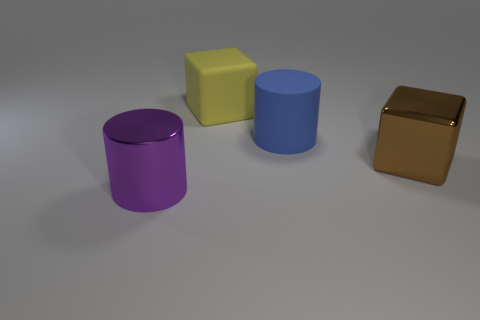Are there any other things that have the same size as the yellow rubber thing?
Ensure brevity in your answer.  Yes. What number of objects are both in front of the yellow object and to the right of the big purple metal object?
Your response must be concise. 2. What number of objects are objects that are right of the large yellow matte object or shiny objects that are on the left side of the big brown metallic thing?
Provide a succinct answer. 3. How many other things are there of the same shape as the blue thing?
Your answer should be very brief. 1. Is the color of the large shiny thing on the right side of the large yellow thing the same as the metallic cylinder?
Provide a short and direct response. No. How many other things are there of the same size as the purple cylinder?
Your answer should be very brief. 3. Do the large purple thing and the big blue object have the same material?
Provide a short and direct response. No. There is a cylinder behind the large metal cylinder left of the big blue thing; what is its color?
Provide a short and direct response. Blue. What size is the matte object that is the same shape as the purple metal thing?
Your response must be concise. Large. Is the color of the matte cylinder the same as the shiny cylinder?
Keep it short and to the point. No. 